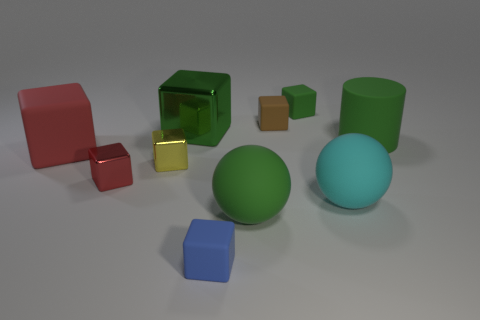Subtract all green cylinders. How many red blocks are left? 2 Subtract all blue blocks. How many blocks are left? 6 Subtract all green cubes. How many cubes are left? 5 Subtract all cylinders. How many objects are left? 9 Subtract 1 green cylinders. How many objects are left? 9 Subtract all red cubes. Subtract all yellow cylinders. How many cubes are left? 5 Subtract all small matte blocks. Subtract all yellow metal objects. How many objects are left? 6 Add 8 small brown matte blocks. How many small brown matte blocks are left? 9 Add 7 yellow blocks. How many yellow blocks exist? 8 